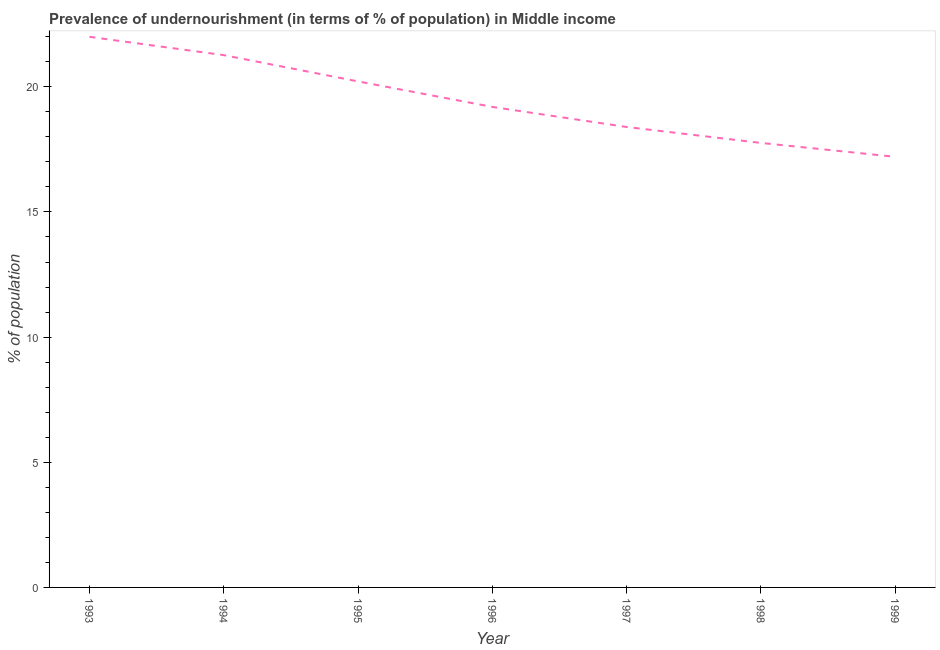What is the percentage of undernourished population in 1996?
Your answer should be compact. 19.2. Across all years, what is the maximum percentage of undernourished population?
Keep it short and to the point. 22. Across all years, what is the minimum percentage of undernourished population?
Make the answer very short. 17.2. In which year was the percentage of undernourished population maximum?
Offer a very short reply. 1993. In which year was the percentage of undernourished population minimum?
Offer a terse response. 1999. What is the sum of the percentage of undernourished population?
Keep it short and to the point. 136.03. What is the difference between the percentage of undernourished population in 1994 and 1995?
Keep it short and to the point. 1.05. What is the average percentage of undernourished population per year?
Ensure brevity in your answer.  19.43. What is the median percentage of undernourished population?
Provide a short and direct response. 19.2. Do a majority of the years between 1998 and 1993 (inclusive) have percentage of undernourished population greater than 11 %?
Your answer should be very brief. Yes. What is the ratio of the percentage of undernourished population in 1993 to that in 1996?
Give a very brief answer. 1.15. Is the percentage of undernourished population in 1997 less than that in 1998?
Give a very brief answer. No. What is the difference between the highest and the second highest percentage of undernourished population?
Your response must be concise. 0.73. What is the difference between the highest and the lowest percentage of undernourished population?
Offer a terse response. 4.79. In how many years, is the percentage of undernourished population greater than the average percentage of undernourished population taken over all years?
Make the answer very short. 3. How many lines are there?
Ensure brevity in your answer.  1. How many years are there in the graph?
Offer a terse response. 7. Are the values on the major ticks of Y-axis written in scientific E-notation?
Offer a terse response. No. What is the title of the graph?
Provide a short and direct response. Prevalence of undernourishment (in terms of % of population) in Middle income. What is the label or title of the Y-axis?
Give a very brief answer. % of population. What is the % of population in 1993?
Offer a terse response. 22. What is the % of population of 1994?
Offer a terse response. 21.27. What is the % of population in 1995?
Make the answer very short. 20.22. What is the % of population in 1996?
Provide a succinct answer. 19.2. What is the % of population in 1997?
Provide a short and direct response. 18.4. What is the % of population of 1998?
Provide a short and direct response. 17.76. What is the % of population of 1999?
Your answer should be very brief. 17.2. What is the difference between the % of population in 1993 and 1994?
Offer a very short reply. 0.73. What is the difference between the % of population in 1993 and 1995?
Ensure brevity in your answer.  1.78. What is the difference between the % of population in 1993 and 1996?
Offer a terse response. 2.8. What is the difference between the % of population in 1993 and 1997?
Ensure brevity in your answer.  3.6. What is the difference between the % of population in 1993 and 1998?
Keep it short and to the point. 4.24. What is the difference between the % of population in 1993 and 1999?
Your response must be concise. 4.79. What is the difference between the % of population in 1994 and 1995?
Provide a succinct answer. 1.05. What is the difference between the % of population in 1994 and 1996?
Your answer should be very brief. 2.07. What is the difference between the % of population in 1994 and 1997?
Your response must be concise. 2.87. What is the difference between the % of population in 1994 and 1998?
Your response must be concise. 3.51. What is the difference between the % of population in 1994 and 1999?
Make the answer very short. 4.06. What is the difference between the % of population in 1995 and 1996?
Make the answer very short. 1.02. What is the difference between the % of population in 1995 and 1997?
Make the answer very short. 1.82. What is the difference between the % of population in 1995 and 1998?
Make the answer very short. 2.46. What is the difference between the % of population in 1995 and 1999?
Provide a succinct answer. 3.01. What is the difference between the % of population in 1996 and 1997?
Give a very brief answer. 0.8. What is the difference between the % of population in 1996 and 1998?
Ensure brevity in your answer.  1.44. What is the difference between the % of population in 1996 and 1999?
Ensure brevity in your answer.  1.99. What is the difference between the % of population in 1997 and 1998?
Ensure brevity in your answer.  0.64. What is the difference between the % of population in 1997 and 1999?
Provide a short and direct response. 1.19. What is the difference between the % of population in 1998 and 1999?
Offer a very short reply. 0.55. What is the ratio of the % of population in 1993 to that in 1994?
Your answer should be compact. 1.03. What is the ratio of the % of population in 1993 to that in 1995?
Give a very brief answer. 1.09. What is the ratio of the % of population in 1993 to that in 1996?
Offer a very short reply. 1.15. What is the ratio of the % of population in 1993 to that in 1997?
Provide a short and direct response. 1.2. What is the ratio of the % of population in 1993 to that in 1998?
Provide a succinct answer. 1.24. What is the ratio of the % of population in 1993 to that in 1999?
Ensure brevity in your answer.  1.28. What is the ratio of the % of population in 1994 to that in 1995?
Your answer should be very brief. 1.05. What is the ratio of the % of population in 1994 to that in 1996?
Your answer should be compact. 1.11. What is the ratio of the % of population in 1994 to that in 1997?
Provide a short and direct response. 1.16. What is the ratio of the % of population in 1994 to that in 1998?
Keep it short and to the point. 1.2. What is the ratio of the % of population in 1994 to that in 1999?
Your response must be concise. 1.24. What is the ratio of the % of population in 1995 to that in 1996?
Provide a succinct answer. 1.05. What is the ratio of the % of population in 1995 to that in 1997?
Offer a very short reply. 1.1. What is the ratio of the % of population in 1995 to that in 1998?
Make the answer very short. 1.14. What is the ratio of the % of population in 1995 to that in 1999?
Ensure brevity in your answer.  1.18. What is the ratio of the % of population in 1996 to that in 1997?
Offer a terse response. 1.04. What is the ratio of the % of population in 1996 to that in 1998?
Keep it short and to the point. 1.08. What is the ratio of the % of population in 1996 to that in 1999?
Give a very brief answer. 1.12. What is the ratio of the % of population in 1997 to that in 1998?
Give a very brief answer. 1.04. What is the ratio of the % of population in 1997 to that in 1999?
Make the answer very short. 1.07. What is the ratio of the % of population in 1998 to that in 1999?
Ensure brevity in your answer.  1.03. 